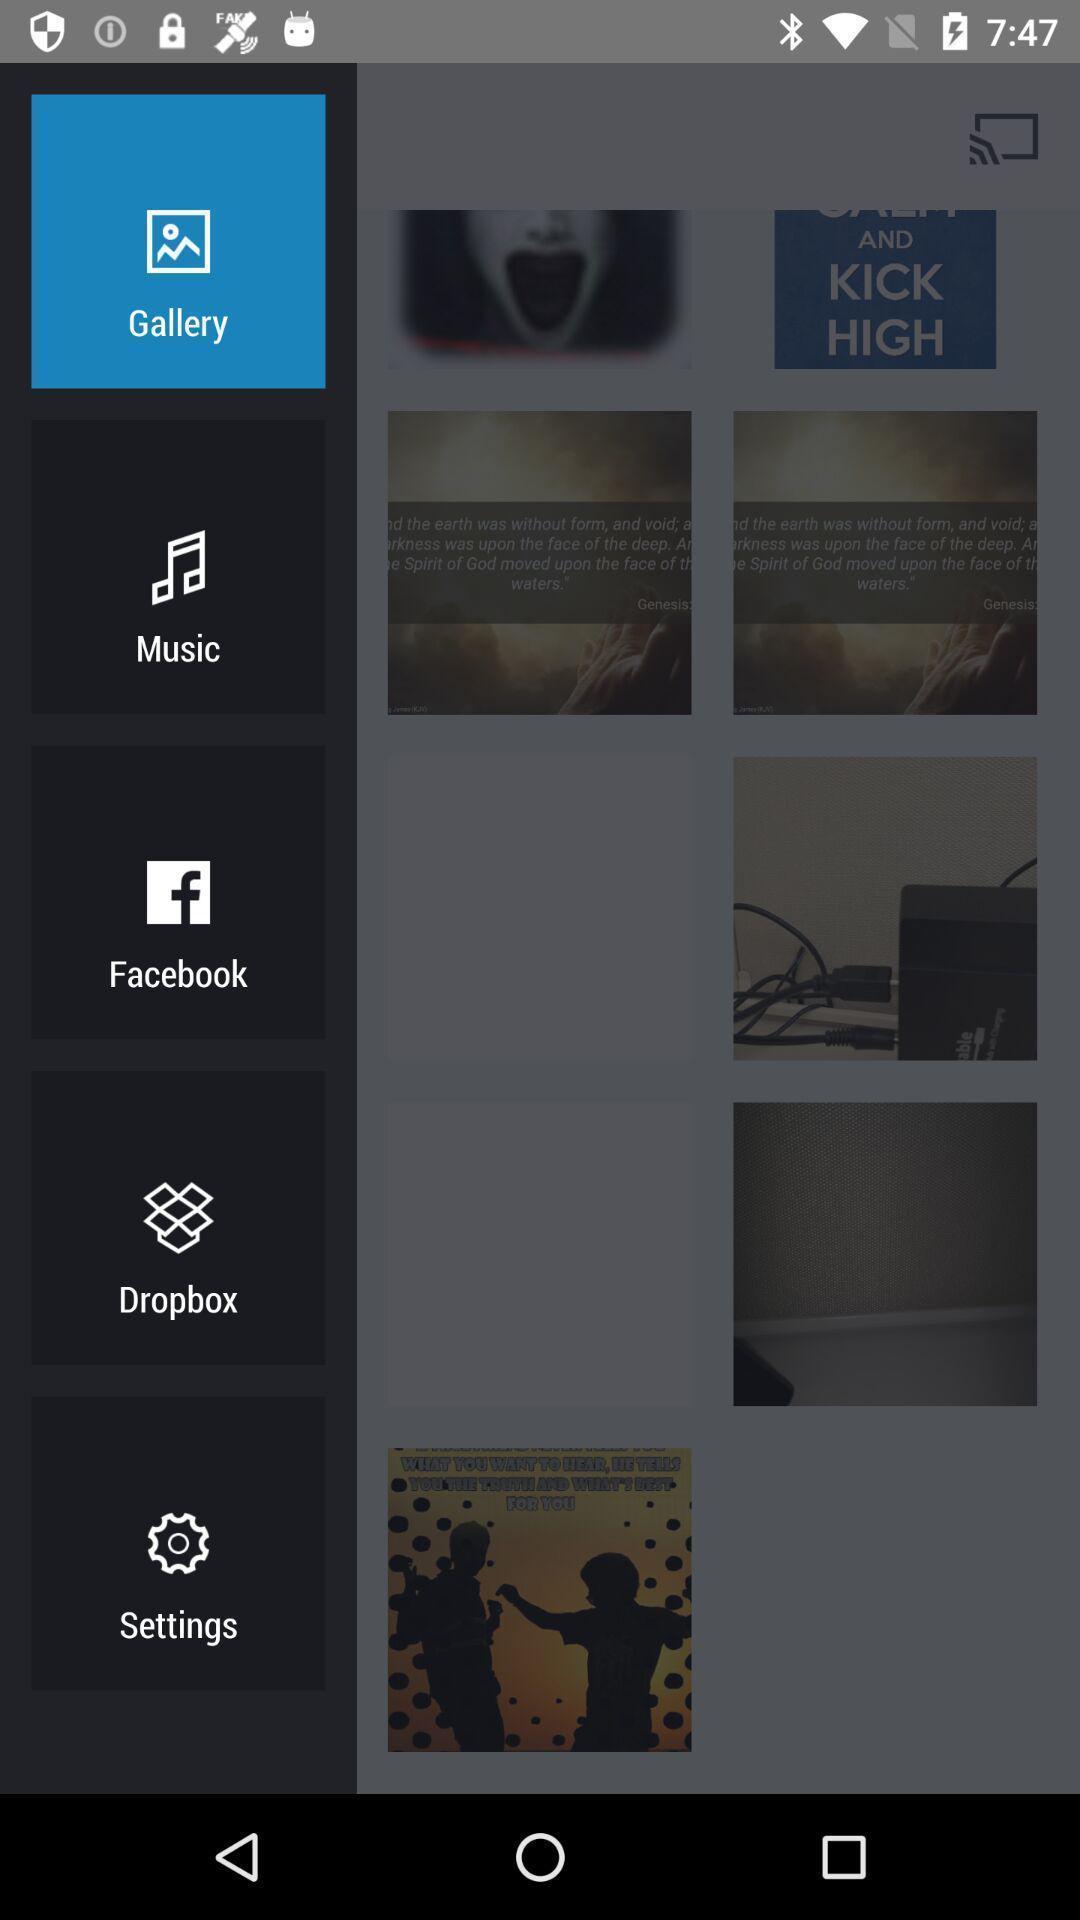Give me a summary of this screen capture. Pop up notification of different options. 